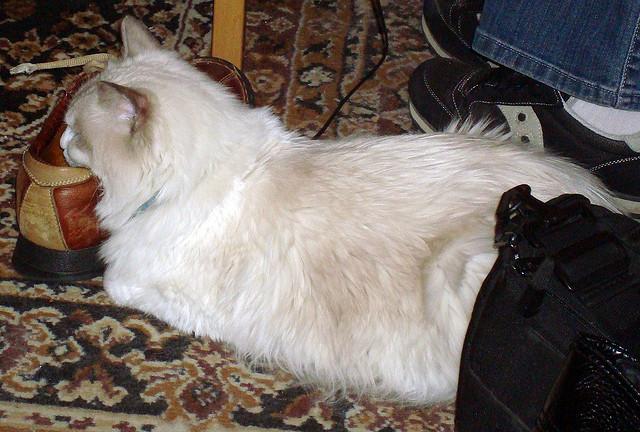Does this cat like shoes?
Concise answer only. Yes. Are the shoelaces tied?
Keep it brief. Yes. Where is the cat?
Write a very short answer. Floor. 